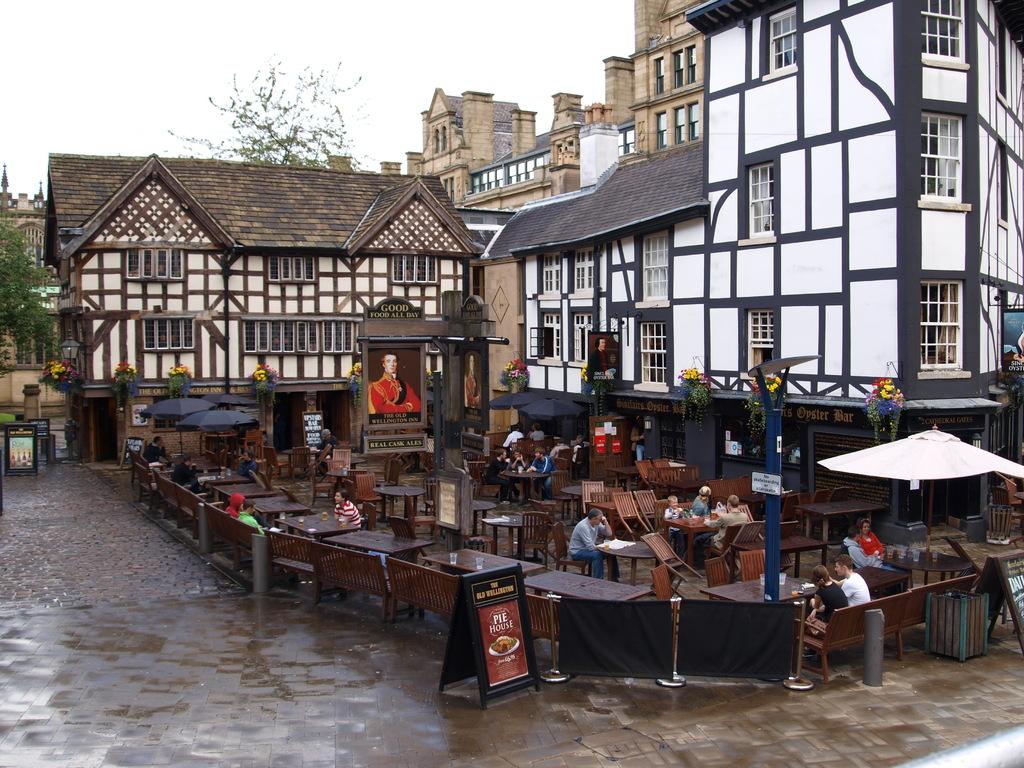What restaurant is being advertised?
Offer a terse response. Unanswerable. 